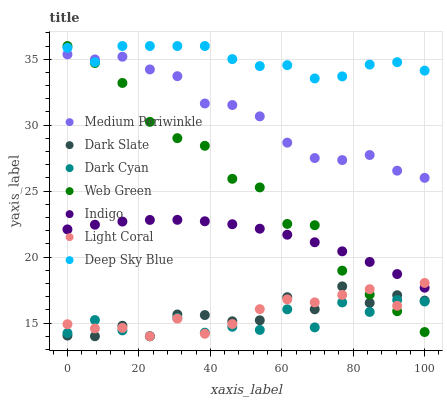Does Dark Cyan have the minimum area under the curve?
Answer yes or no. Yes. Does Deep Sky Blue have the maximum area under the curve?
Answer yes or no. Yes. Does Medium Periwinkle have the minimum area under the curve?
Answer yes or no. No. Does Medium Periwinkle have the maximum area under the curve?
Answer yes or no. No. Is Indigo the smoothest?
Answer yes or no. Yes. Is Dark Cyan the roughest?
Answer yes or no. Yes. Is Medium Periwinkle the smoothest?
Answer yes or no. No. Is Medium Periwinkle the roughest?
Answer yes or no. No. Does Light Coral have the lowest value?
Answer yes or no. Yes. Does Medium Periwinkle have the lowest value?
Answer yes or no. No. Does Deep Sky Blue have the highest value?
Answer yes or no. Yes. Does Medium Periwinkle have the highest value?
Answer yes or no. No. Is Dark Slate less than Medium Periwinkle?
Answer yes or no. Yes. Is Deep Sky Blue greater than Dark Slate?
Answer yes or no. Yes. Does Dark Cyan intersect Web Green?
Answer yes or no. Yes. Is Dark Cyan less than Web Green?
Answer yes or no. No. Is Dark Cyan greater than Web Green?
Answer yes or no. No. Does Dark Slate intersect Medium Periwinkle?
Answer yes or no. No. 